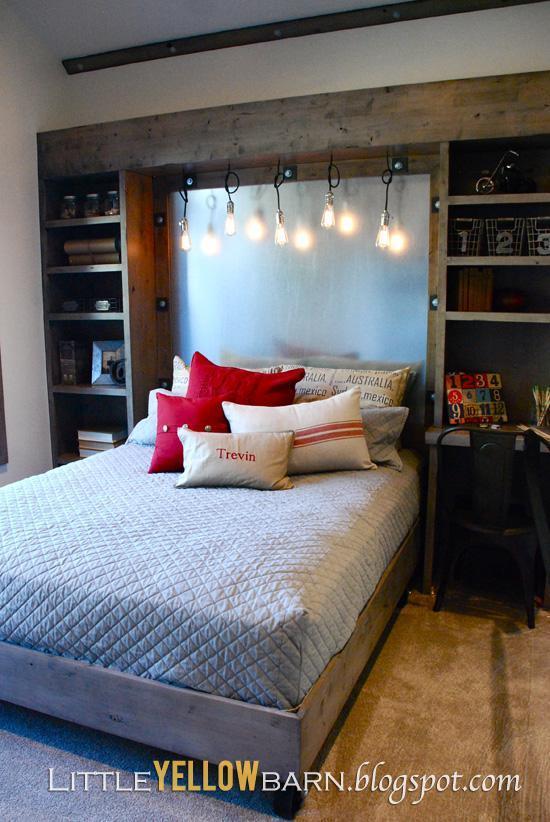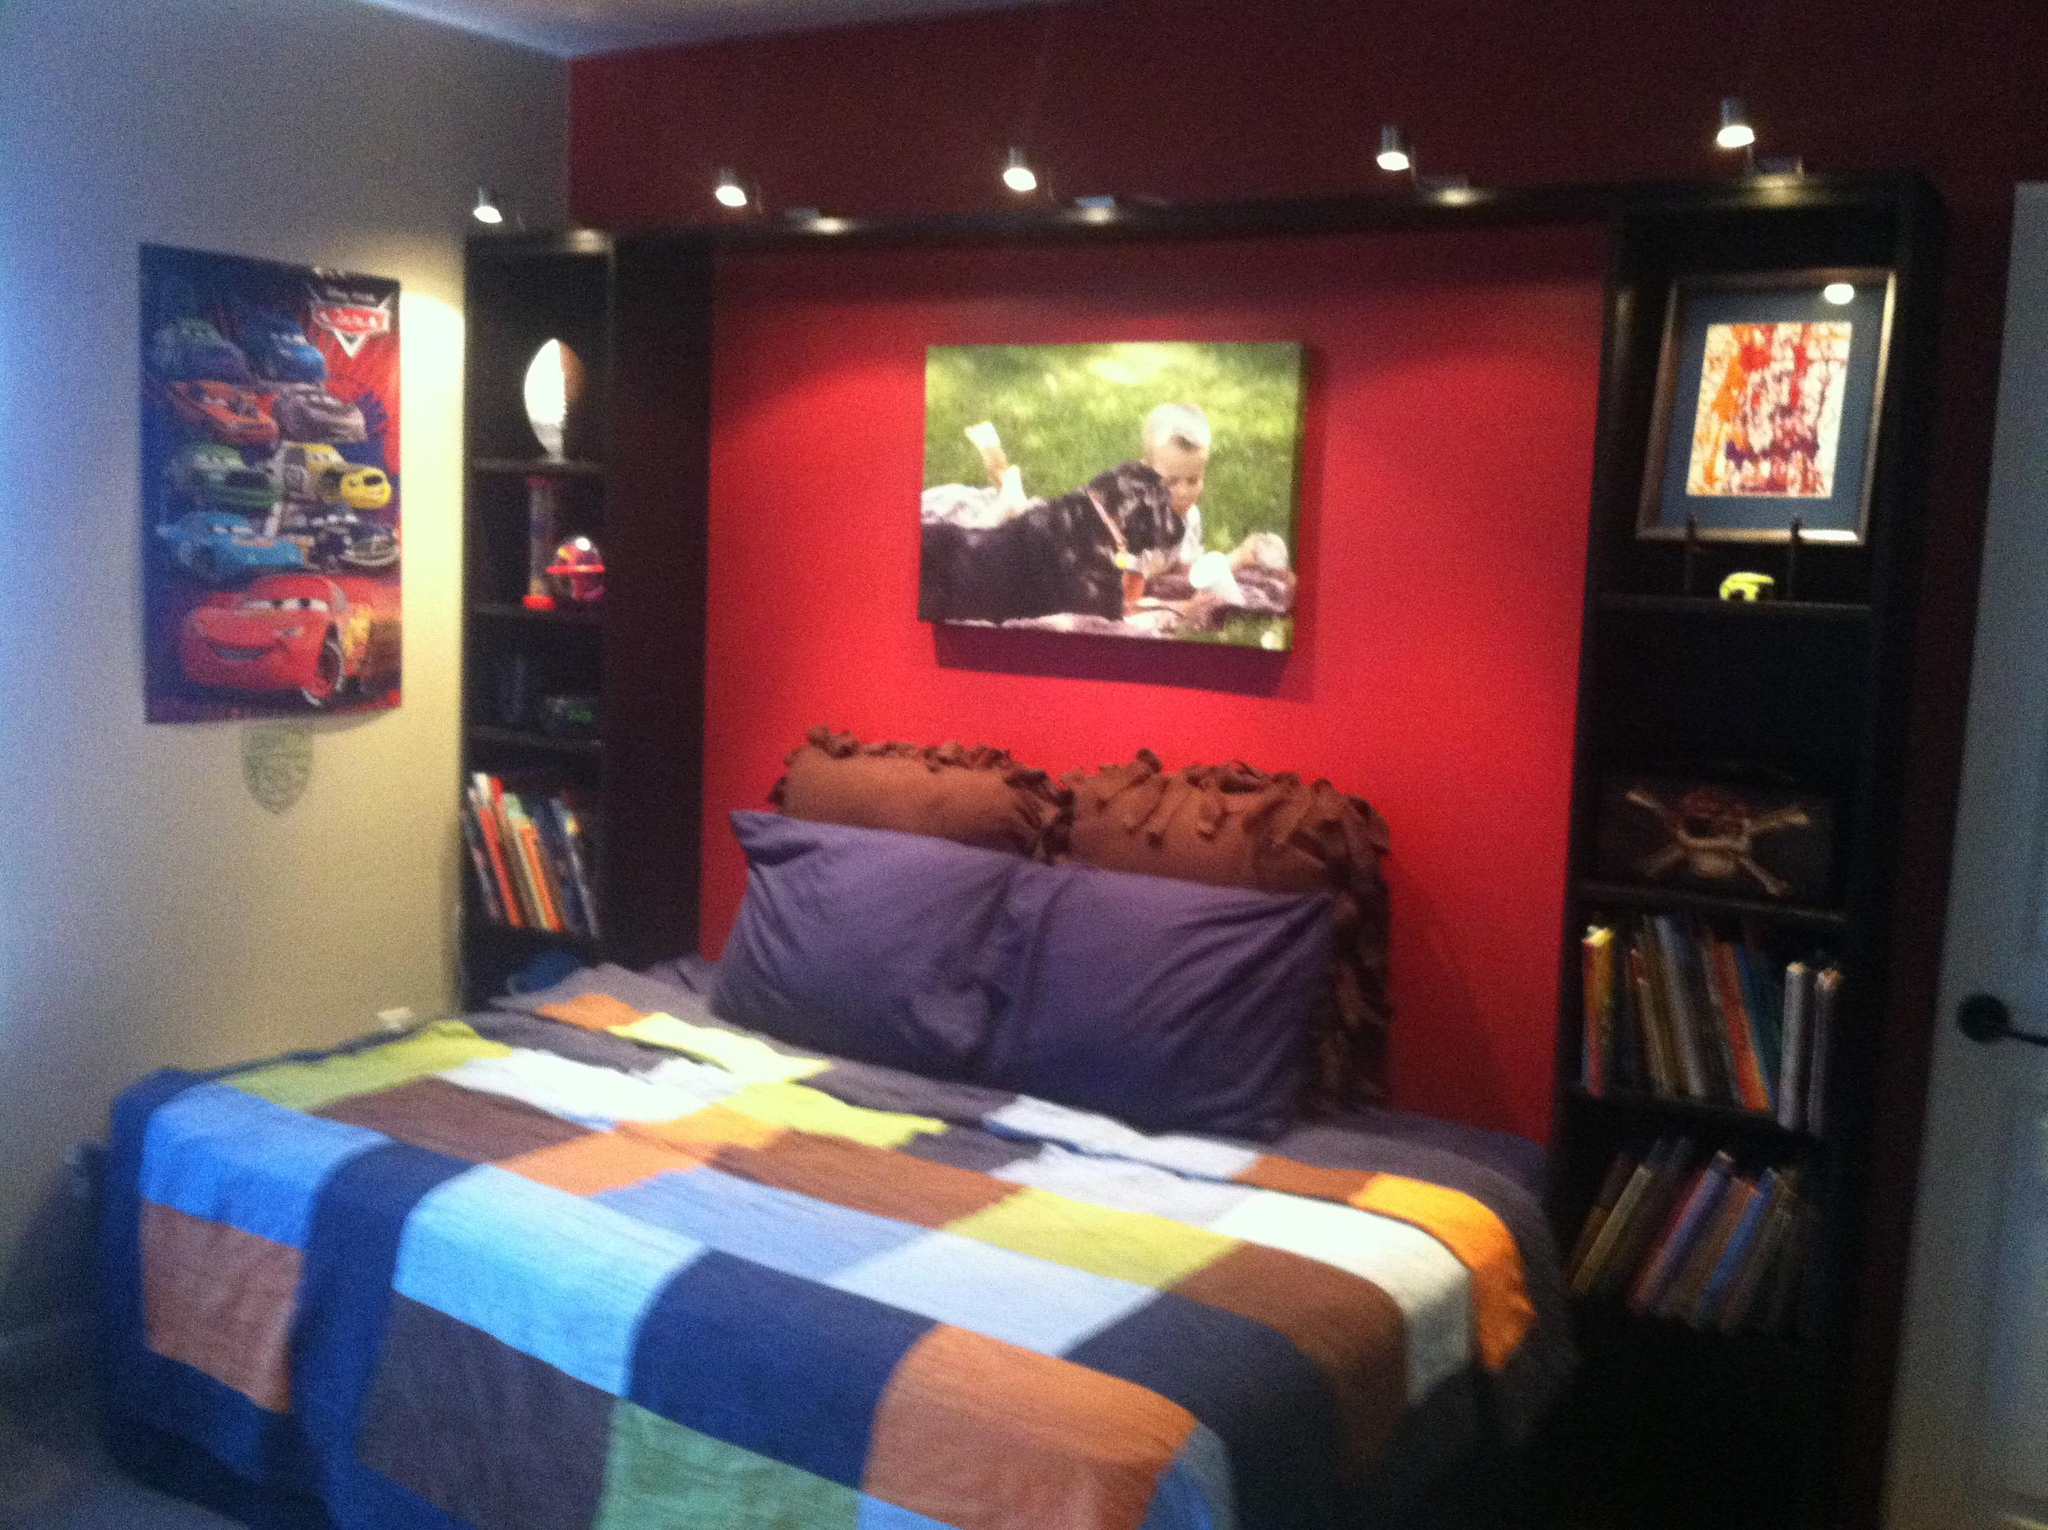The first image is the image on the left, the second image is the image on the right. Considering the images on both sides, is "AN image shows a bed with a patterned bedspread, flanked by black shelving joined by a top bridge." valid? Answer yes or no. Yes. The first image is the image on the left, the second image is the image on the right. For the images displayed, is the sentence "None of the beds are bunk beds." factually correct? Answer yes or no. Yes. 